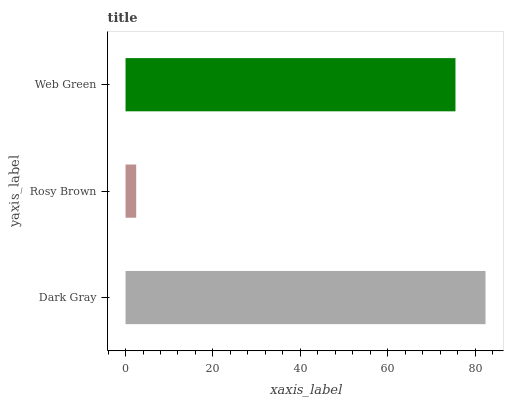Is Rosy Brown the minimum?
Answer yes or no. Yes. Is Dark Gray the maximum?
Answer yes or no. Yes. Is Web Green the minimum?
Answer yes or no. No. Is Web Green the maximum?
Answer yes or no. No. Is Web Green greater than Rosy Brown?
Answer yes or no. Yes. Is Rosy Brown less than Web Green?
Answer yes or no. Yes. Is Rosy Brown greater than Web Green?
Answer yes or no. No. Is Web Green less than Rosy Brown?
Answer yes or no. No. Is Web Green the high median?
Answer yes or no. Yes. Is Web Green the low median?
Answer yes or no. Yes. Is Dark Gray the high median?
Answer yes or no. No. Is Rosy Brown the low median?
Answer yes or no. No. 